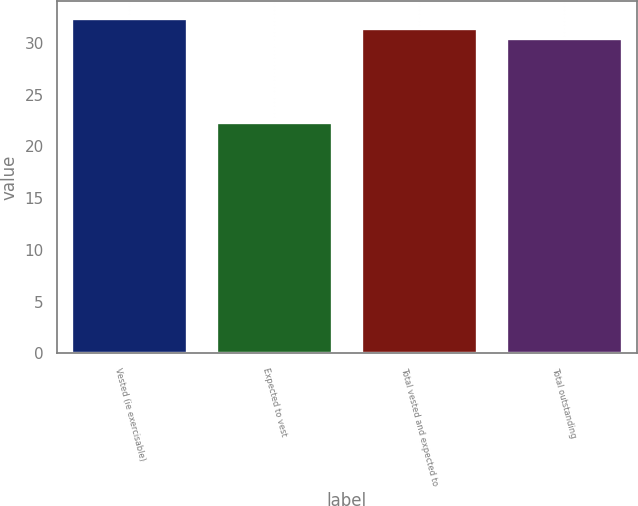Convert chart. <chart><loc_0><loc_0><loc_500><loc_500><bar_chart><fcel>Vested (ie exercisable)<fcel>Expected to vest<fcel>Total vested and expected to<fcel>Total outstanding<nl><fcel>32.41<fcel>22.39<fcel>31.46<fcel>30.51<nl></chart> 